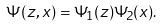Convert formula to latex. <formula><loc_0><loc_0><loc_500><loc_500>\Psi ( z , x ) = \Psi _ { 1 } ( z ) \Psi _ { 2 } ( x ) .</formula> 